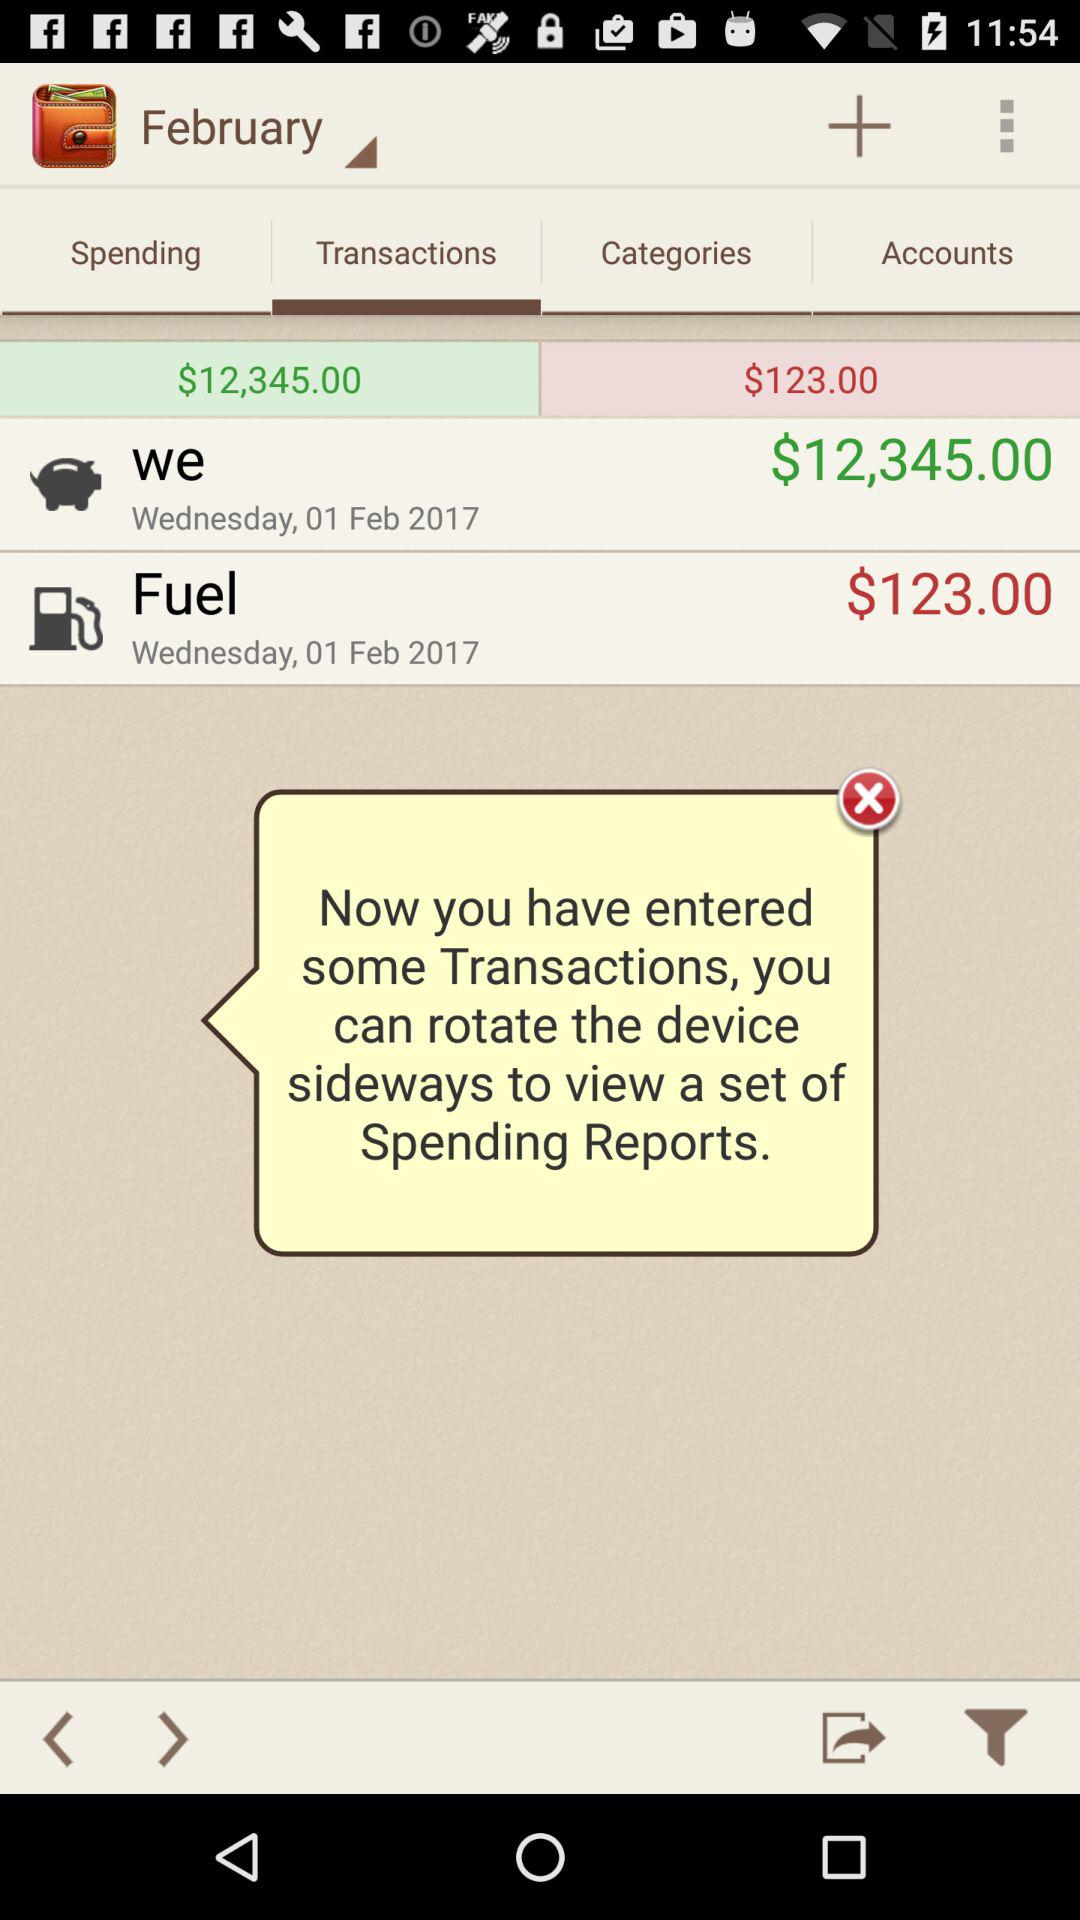What month are these transactions from? These transactions are from February. 